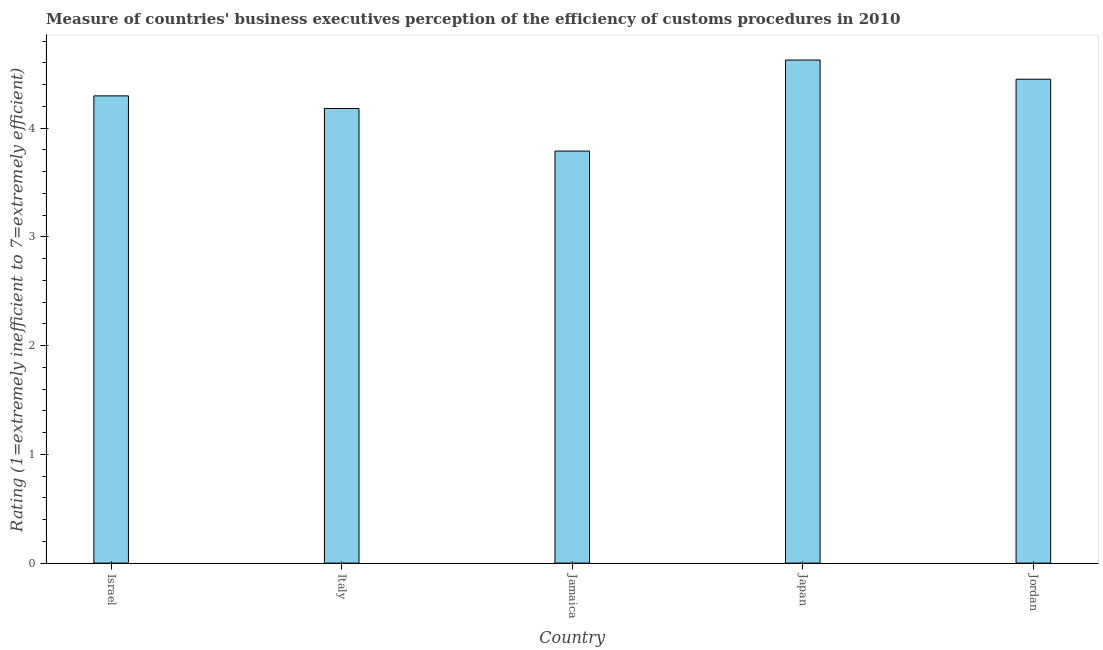Does the graph contain any zero values?
Your answer should be very brief. No. What is the title of the graph?
Keep it short and to the point. Measure of countries' business executives perception of the efficiency of customs procedures in 2010. What is the label or title of the X-axis?
Offer a very short reply. Country. What is the label or title of the Y-axis?
Your answer should be very brief. Rating (1=extremely inefficient to 7=extremely efficient). What is the rating measuring burden of customs procedure in Jordan?
Keep it short and to the point. 4.45. Across all countries, what is the maximum rating measuring burden of customs procedure?
Offer a very short reply. 4.63. Across all countries, what is the minimum rating measuring burden of customs procedure?
Provide a succinct answer. 3.79. In which country was the rating measuring burden of customs procedure minimum?
Offer a terse response. Jamaica. What is the sum of the rating measuring burden of customs procedure?
Keep it short and to the point. 21.35. What is the difference between the rating measuring burden of customs procedure in Italy and Jamaica?
Make the answer very short. 0.39. What is the average rating measuring burden of customs procedure per country?
Keep it short and to the point. 4.27. What is the median rating measuring burden of customs procedure?
Your response must be concise. 4.3. In how many countries, is the rating measuring burden of customs procedure greater than 3.2 ?
Your answer should be very brief. 5. What is the ratio of the rating measuring burden of customs procedure in Jamaica to that in Jordan?
Your answer should be compact. 0.85. Is the difference between the rating measuring burden of customs procedure in Japan and Jordan greater than the difference between any two countries?
Provide a succinct answer. No. What is the difference between the highest and the second highest rating measuring burden of customs procedure?
Keep it short and to the point. 0.18. What is the difference between the highest and the lowest rating measuring burden of customs procedure?
Provide a succinct answer. 0.84. How many bars are there?
Offer a very short reply. 5. How many countries are there in the graph?
Keep it short and to the point. 5. Are the values on the major ticks of Y-axis written in scientific E-notation?
Provide a short and direct response. No. What is the Rating (1=extremely inefficient to 7=extremely efficient) of Israel?
Your response must be concise. 4.3. What is the Rating (1=extremely inefficient to 7=extremely efficient) of Italy?
Ensure brevity in your answer.  4.18. What is the Rating (1=extremely inefficient to 7=extremely efficient) in Jamaica?
Offer a terse response. 3.79. What is the Rating (1=extremely inefficient to 7=extremely efficient) of Japan?
Offer a very short reply. 4.63. What is the Rating (1=extremely inefficient to 7=extremely efficient) of Jordan?
Provide a short and direct response. 4.45. What is the difference between the Rating (1=extremely inefficient to 7=extremely efficient) in Israel and Italy?
Make the answer very short. 0.12. What is the difference between the Rating (1=extremely inefficient to 7=extremely efficient) in Israel and Jamaica?
Offer a terse response. 0.51. What is the difference between the Rating (1=extremely inefficient to 7=extremely efficient) in Israel and Japan?
Provide a short and direct response. -0.33. What is the difference between the Rating (1=extremely inefficient to 7=extremely efficient) in Israel and Jordan?
Provide a succinct answer. -0.15. What is the difference between the Rating (1=extremely inefficient to 7=extremely efficient) in Italy and Jamaica?
Provide a succinct answer. 0.39. What is the difference between the Rating (1=extremely inefficient to 7=extremely efficient) in Italy and Japan?
Your answer should be very brief. -0.45. What is the difference between the Rating (1=extremely inefficient to 7=extremely efficient) in Italy and Jordan?
Make the answer very short. -0.27. What is the difference between the Rating (1=extremely inefficient to 7=extremely efficient) in Jamaica and Japan?
Make the answer very short. -0.84. What is the difference between the Rating (1=extremely inefficient to 7=extremely efficient) in Jamaica and Jordan?
Keep it short and to the point. -0.66. What is the difference between the Rating (1=extremely inefficient to 7=extremely efficient) in Japan and Jordan?
Make the answer very short. 0.18. What is the ratio of the Rating (1=extremely inefficient to 7=extremely efficient) in Israel to that in Italy?
Offer a very short reply. 1.03. What is the ratio of the Rating (1=extremely inefficient to 7=extremely efficient) in Israel to that in Jamaica?
Provide a short and direct response. 1.13. What is the ratio of the Rating (1=extremely inefficient to 7=extremely efficient) in Israel to that in Japan?
Your answer should be compact. 0.93. What is the ratio of the Rating (1=extremely inefficient to 7=extremely efficient) in Israel to that in Jordan?
Your response must be concise. 0.97. What is the ratio of the Rating (1=extremely inefficient to 7=extremely efficient) in Italy to that in Jamaica?
Make the answer very short. 1.1. What is the ratio of the Rating (1=extremely inefficient to 7=extremely efficient) in Italy to that in Japan?
Offer a very short reply. 0.9. What is the ratio of the Rating (1=extremely inefficient to 7=extremely efficient) in Italy to that in Jordan?
Ensure brevity in your answer.  0.94. What is the ratio of the Rating (1=extremely inefficient to 7=extremely efficient) in Jamaica to that in Japan?
Offer a very short reply. 0.82. What is the ratio of the Rating (1=extremely inefficient to 7=extremely efficient) in Jamaica to that in Jordan?
Give a very brief answer. 0.85. What is the ratio of the Rating (1=extremely inefficient to 7=extremely efficient) in Japan to that in Jordan?
Give a very brief answer. 1.04. 